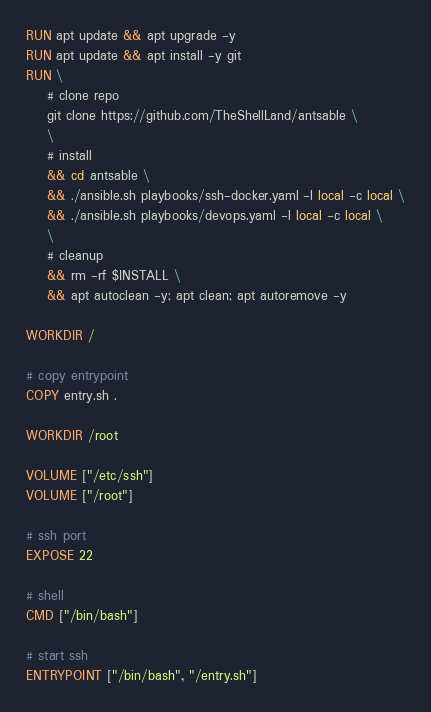<code> <loc_0><loc_0><loc_500><loc_500><_Dockerfile_>RUN apt update && apt upgrade -y
RUN apt update && apt install -y git
RUN \
    # clone repo
    git clone https://github.com/TheShellLand/antsable \
    \
    # install
    && cd antsable \
    && ./ansible.sh playbooks/ssh-docker.yaml -l local -c local \
    && ./ansible.sh playbooks/devops.yaml -l local -c local \
    \
    # cleanup
    && rm -rf $INSTALL \
    && apt autoclean -y; apt clean; apt autoremove -y

WORKDIR /

# copy entrypoint
COPY entry.sh .

WORKDIR /root

VOLUME ["/etc/ssh"]
VOLUME ["/root"]

# ssh port
EXPOSE 22

# shell
CMD ["/bin/bash"]

# start ssh
ENTRYPOINT ["/bin/bash", "/entry.sh"]
</code> 